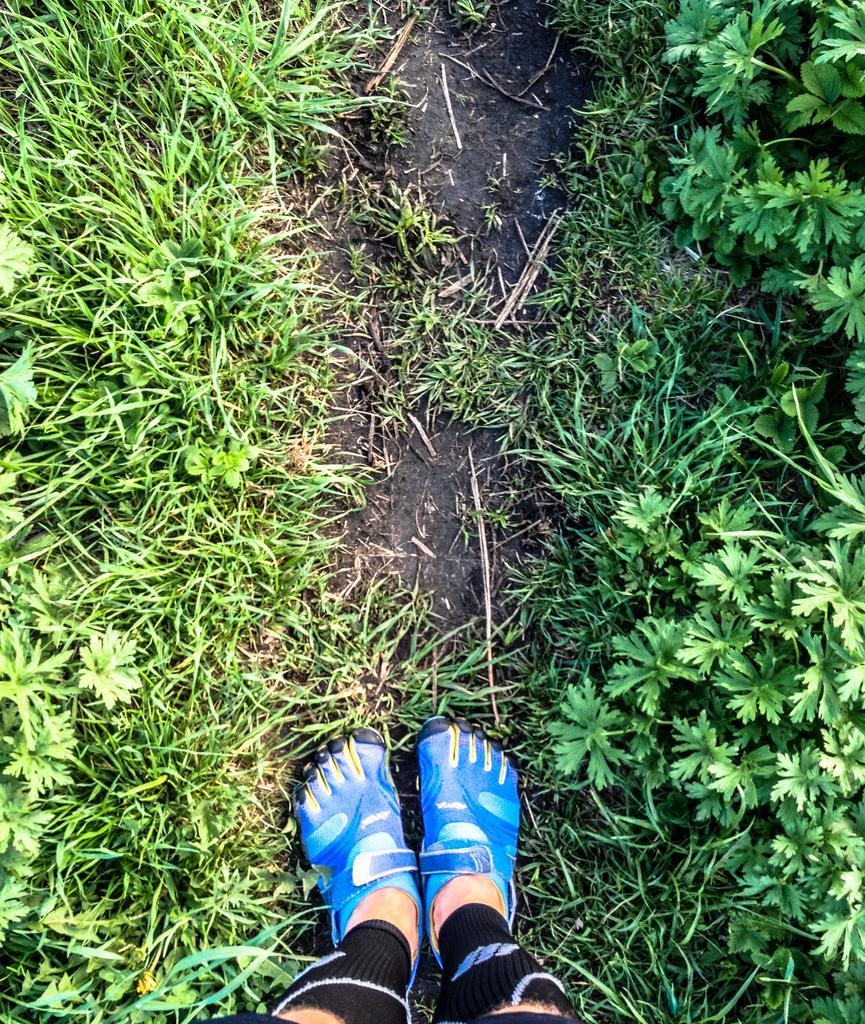Describe this image in one or two sentences. In this picture we see many grass all over the place and two leg at the bottom. 